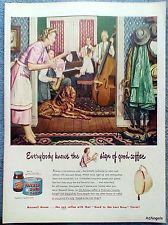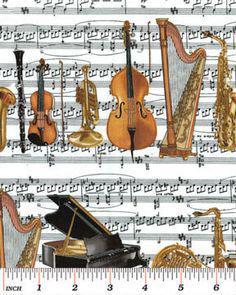The first image is the image on the left, the second image is the image on the right. For the images shown, is this caption "One image shows four art renderings of musical instruments, including saxophone, violin and keyboard, and the other image depicts a person standing and playing a saxophone." true? Answer yes or no. No. 